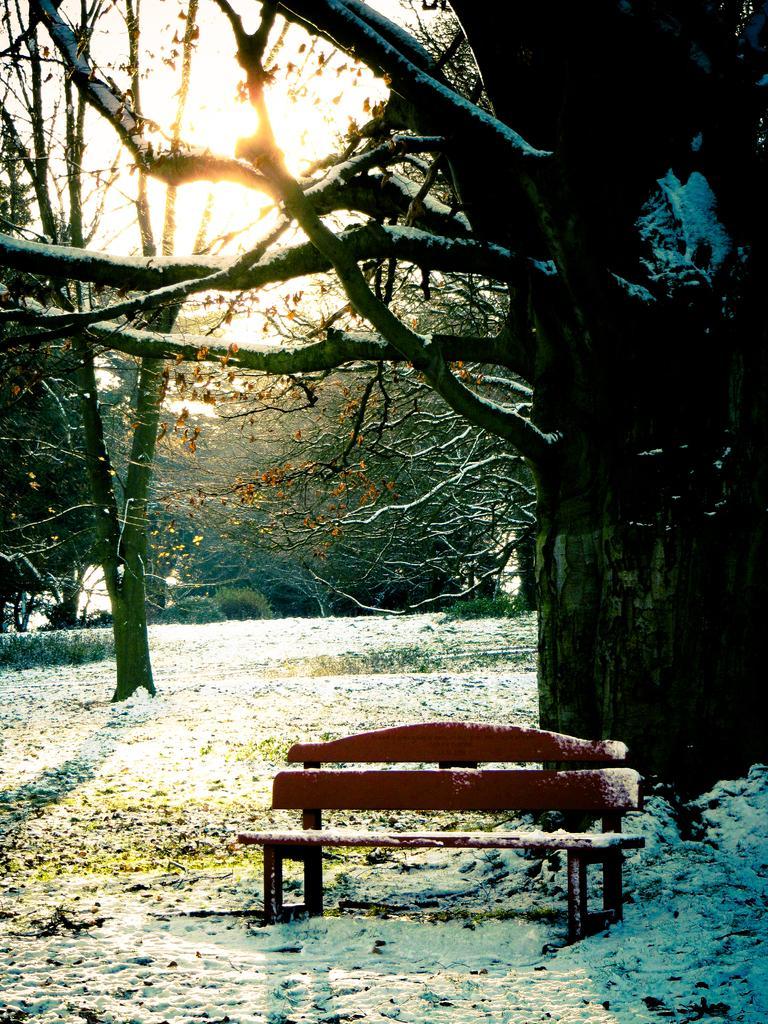In one or two sentences, can you explain what this image depicts? In this image we can see a bench, snow, shredded leaves, trees, sky and sun. 